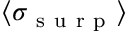Convert formula to latex. <formula><loc_0><loc_0><loc_500><loc_500>\langle \sigma _ { s u r p } \rangle</formula> 